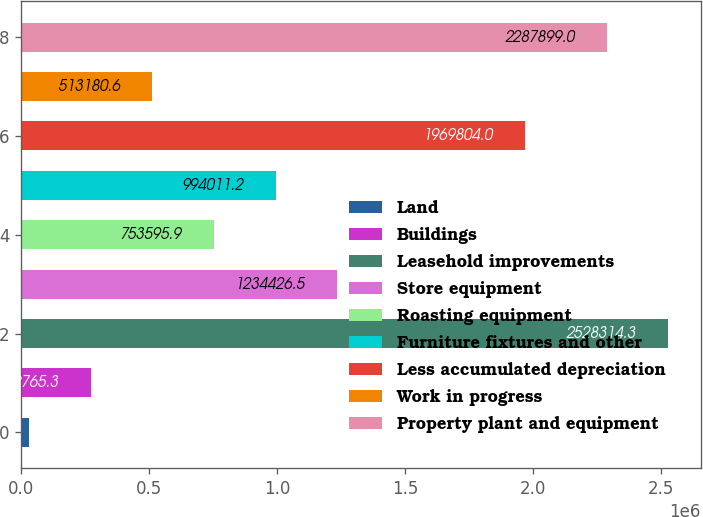Convert chart. <chart><loc_0><loc_0><loc_500><loc_500><bar_chart><fcel>Land<fcel>Buildings<fcel>Leasehold improvements<fcel>Store equipment<fcel>Roasting equipment<fcel>Furniture fixtures and other<fcel>Less accumulated depreciation<fcel>Work in progress<fcel>Property plant and equipment<nl><fcel>32350<fcel>272765<fcel>2.52831e+06<fcel>1.23443e+06<fcel>753596<fcel>994011<fcel>1.9698e+06<fcel>513181<fcel>2.2879e+06<nl></chart> 